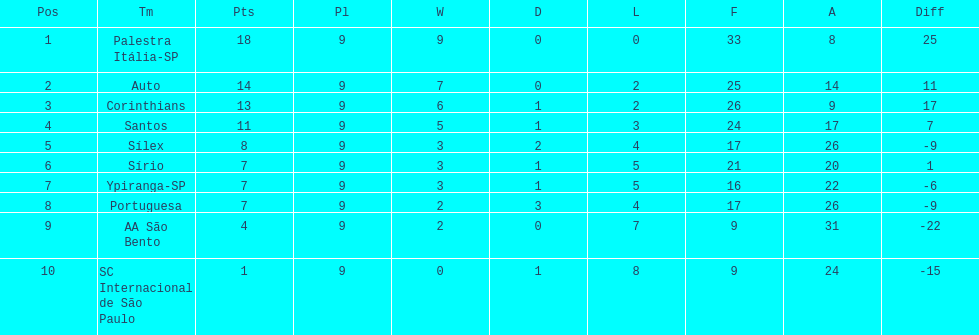Which team was the top scoring team? Palestra Itália-SP. 